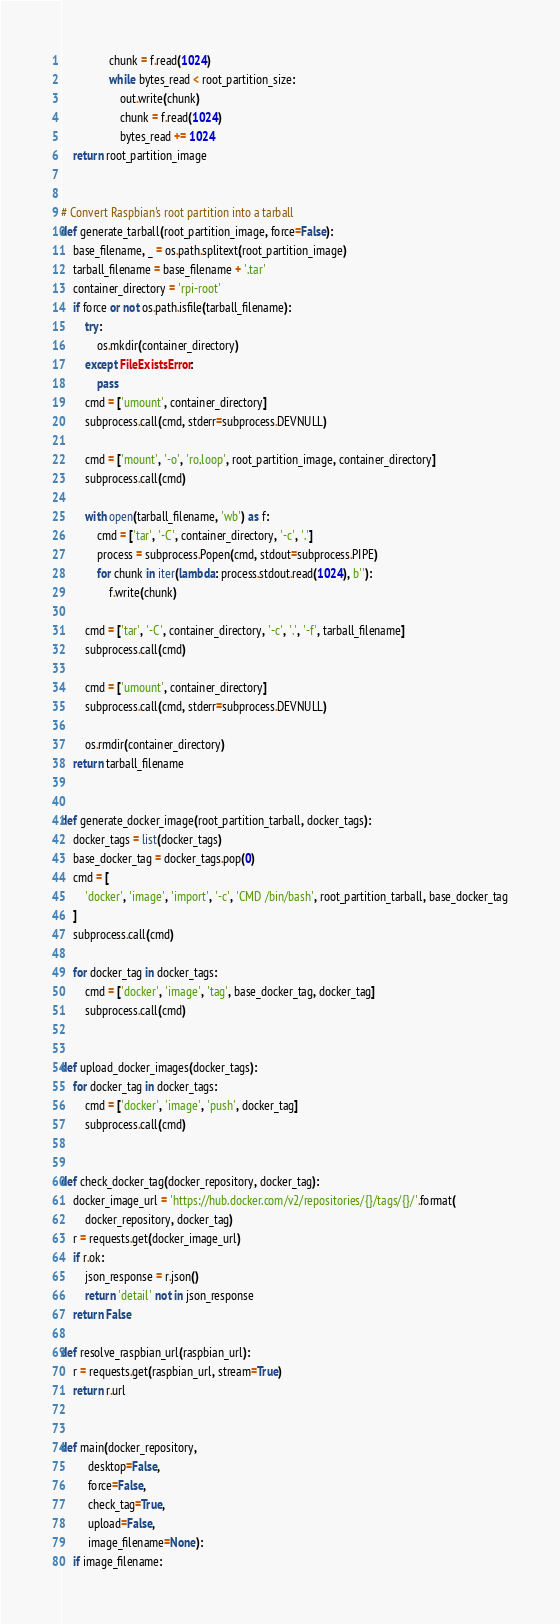<code> <loc_0><loc_0><loc_500><loc_500><_Python_>                chunk = f.read(1024)
                while bytes_read < root_partition_size:
                    out.write(chunk)
                    chunk = f.read(1024)
                    bytes_read += 1024
    return root_partition_image


# Convert Raspbian's root partition into a tarball
def generate_tarball(root_partition_image, force=False):
    base_filename, _ = os.path.splitext(root_partition_image)
    tarball_filename = base_filename + '.tar'
    container_directory = 'rpi-root'
    if force or not os.path.isfile(tarball_filename):
        try:
            os.mkdir(container_directory)
        except FileExistsError:
            pass
        cmd = ['umount', container_directory]
        subprocess.call(cmd, stderr=subprocess.DEVNULL)

        cmd = ['mount', '-o', 'ro,loop', root_partition_image, container_directory]
        subprocess.call(cmd)

        with open(tarball_filename, 'wb') as f:
            cmd = ['tar', '-C', container_directory, '-c', '.']
            process = subprocess.Popen(cmd, stdout=subprocess.PIPE)
            for chunk in iter(lambda: process.stdout.read(1024), b''):
                f.write(chunk)

        cmd = ['tar', '-C', container_directory, '-c', '.', '-f', tarball_filename]
        subprocess.call(cmd)

        cmd = ['umount', container_directory]
        subprocess.call(cmd, stderr=subprocess.DEVNULL)

        os.rmdir(container_directory)
    return tarball_filename


def generate_docker_image(root_partition_tarball, docker_tags):
    docker_tags = list(docker_tags)
    base_docker_tag = docker_tags.pop(0)
    cmd = [
        'docker', 'image', 'import', '-c', 'CMD /bin/bash', root_partition_tarball, base_docker_tag
    ]
    subprocess.call(cmd)

    for docker_tag in docker_tags:
        cmd = ['docker', 'image', 'tag', base_docker_tag, docker_tag]
        subprocess.call(cmd)


def upload_docker_images(docker_tags):
    for docker_tag in docker_tags:
        cmd = ['docker', 'image', 'push', docker_tag]
        subprocess.call(cmd)


def check_docker_tag(docker_repository, docker_tag):
    docker_image_url = 'https://hub.docker.com/v2/repositories/{}/tags/{}/'.format(
        docker_repository, docker_tag)
    r = requests.get(docker_image_url)
    if r.ok:
        json_response = r.json()
        return 'detail' not in json_response
    return False

def resolve_raspbian_url(raspbian_url):
    r = requests.get(raspbian_url, stream=True)
    return r.url


def main(docker_repository,
         desktop=False,
         force=False,
         check_tag=True,
         upload=False,
         image_filename=None):
    if image_filename:</code> 